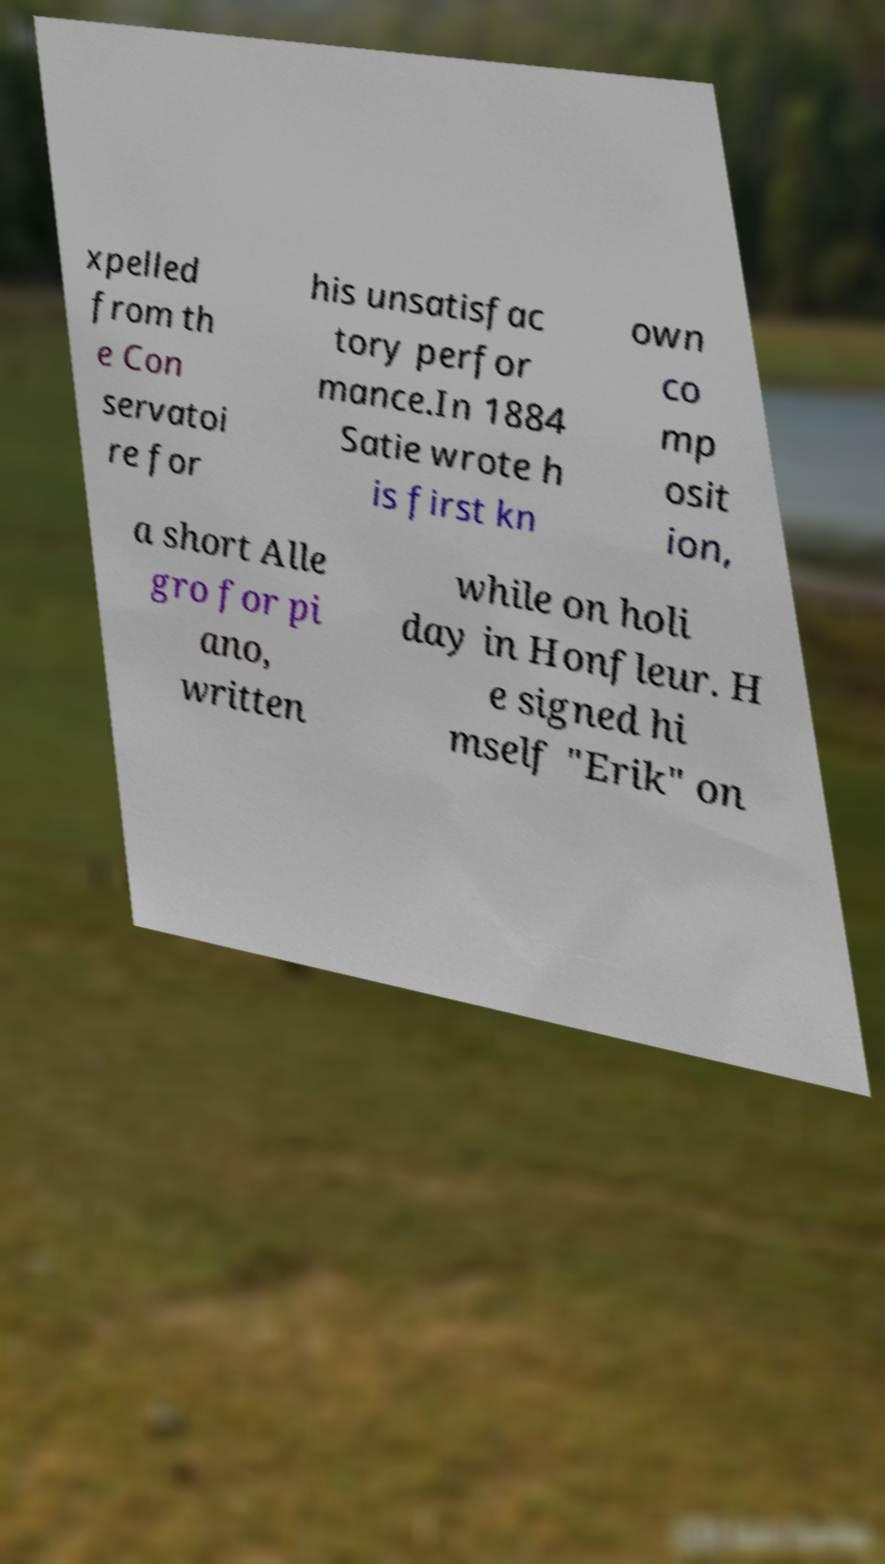For documentation purposes, I need the text within this image transcribed. Could you provide that? xpelled from th e Con servatoi re for his unsatisfac tory perfor mance.In 1884 Satie wrote h is first kn own co mp osit ion, a short Alle gro for pi ano, written while on holi day in Honfleur. H e signed hi mself "Erik" on 